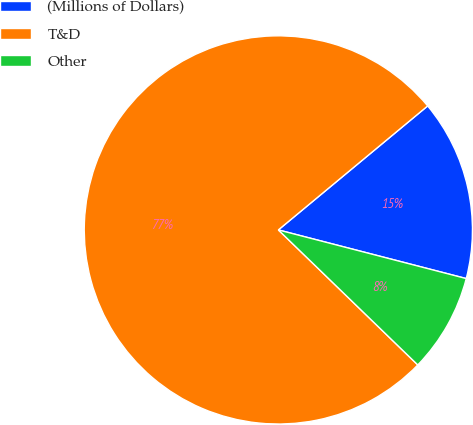<chart> <loc_0><loc_0><loc_500><loc_500><pie_chart><fcel>(Millions of Dollars)<fcel>T&D<fcel>Other<nl><fcel>15.06%<fcel>76.72%<fcel>8.21%<nl></chart> 